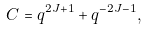<formula> <loc_0><loc_0><loc_500><loc_500>C = q ^ { 2 J + 1 } + q ^ { - 2 J - 1 } ,</formula> 